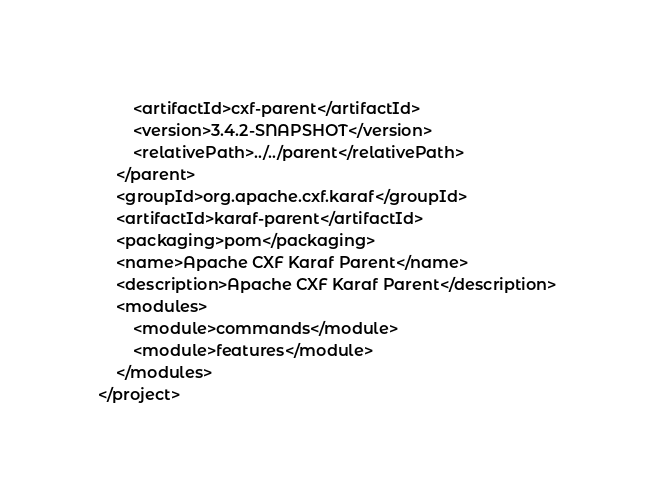<code> <loc_0><loc_0><loc_500><loc_500><_XML_>        <artifactId>cxf-parent</artifactId>
        <version>3.4.2-SNAPSHOT</version>
        <relativePath>../../parent</relativePath>
    </parent>
    <groupId>org.apache.cxf.karaf</groupId>
    <artifactId>karaf-parent</artifactId>
    <packaging>pom</packaging>
    <name>Apache CXF Karaf Parent</name>
    <description>Apache CXF Karaf Parent</description>
    <modules>
        <module>commands</module>
        <module>features</module>
    </modules>
</project>
</code> 